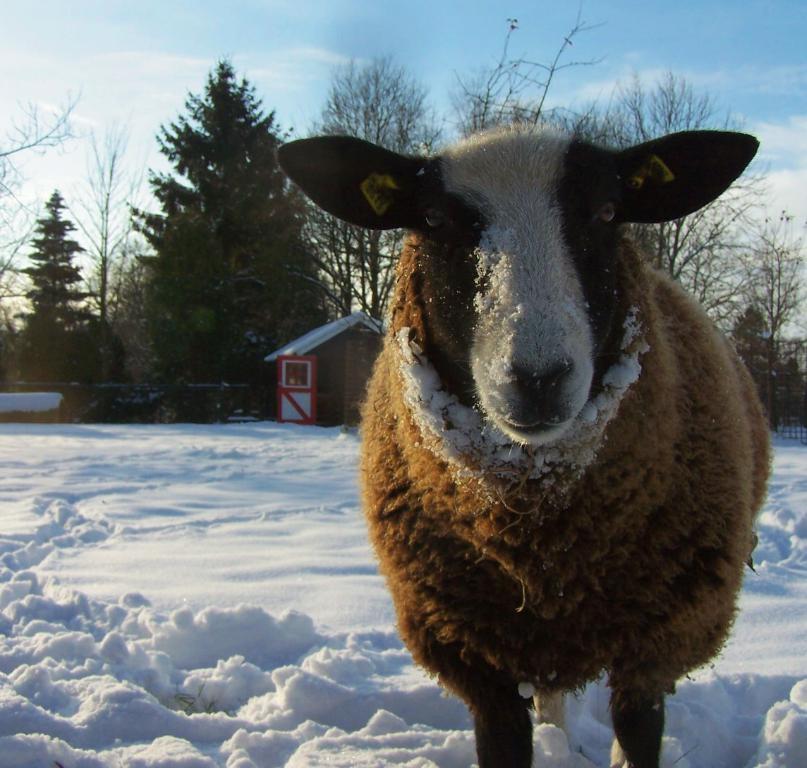Please provide a concise description of this image. In this image we can see there is an animal and a house. There are trees and snow. In the background we can see the sky. 